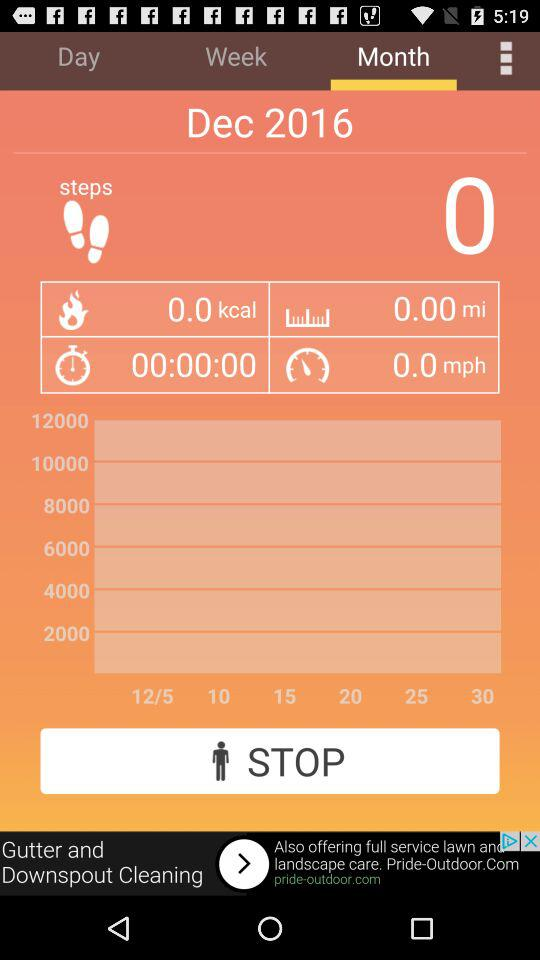What is the burned calorie count for December 2016? The burned calorie count is 0. 